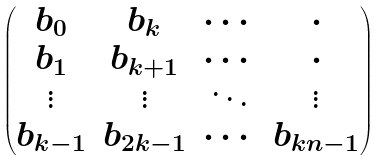<formula> <loc_0><loc_0><loc_500><loc_500>\begin{pmatrix} b _ { 0 } & b _ { k } & \cdots & \cdot \\ b _ { 1 } & b _ { k + 1 } & \cdots & \cdot \\ \vdots & \vdots & \ddots & \vdots \\ b _ { k - 1 } & b _ { 2 k - 1 } & \cdots & b _ { k n - 1 } \end{pmatrix}</formula> 